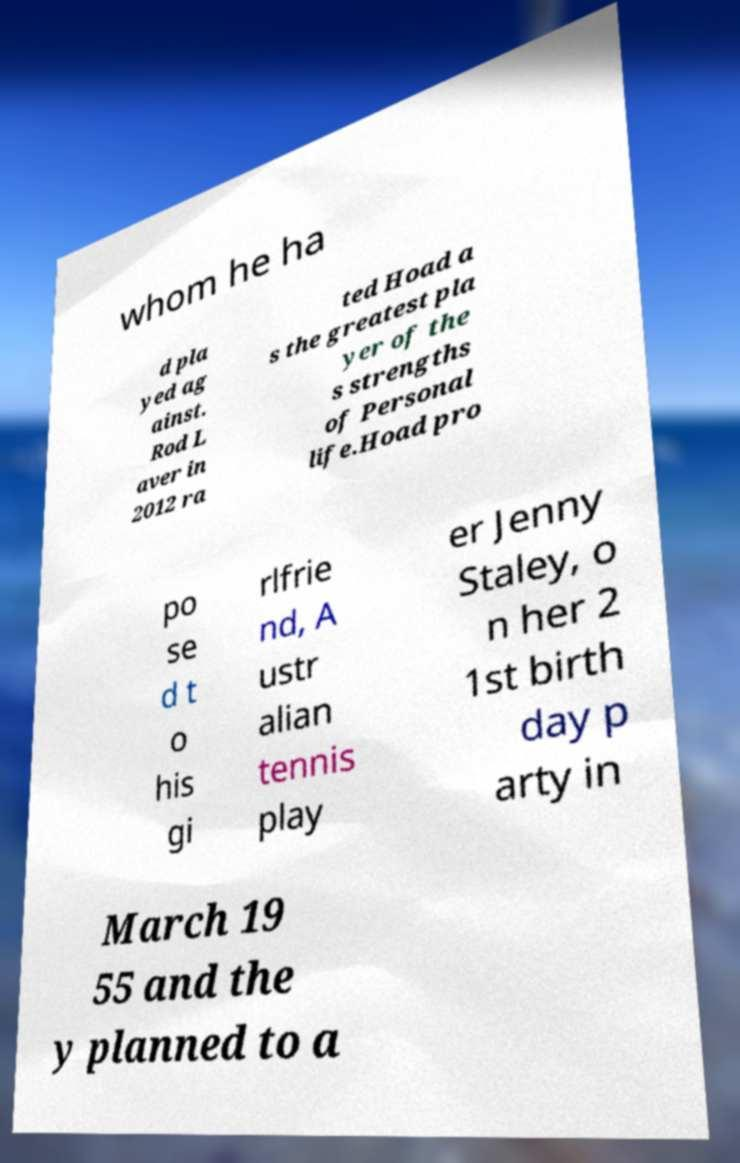Can you accurately transcribe the text from the provided image for me? whom he ha d pla yed ag ainst. Rod L aver in 2012 ra ted Hoad a s the greatest pla yer of the s strengths of Personal life.Hoad pro po se d t o his gi rlfrie nd, A ustr alian tennis play er Jenny Staley, o n her 2 1st birth day p arty in March 19 55 and the y planned to a 